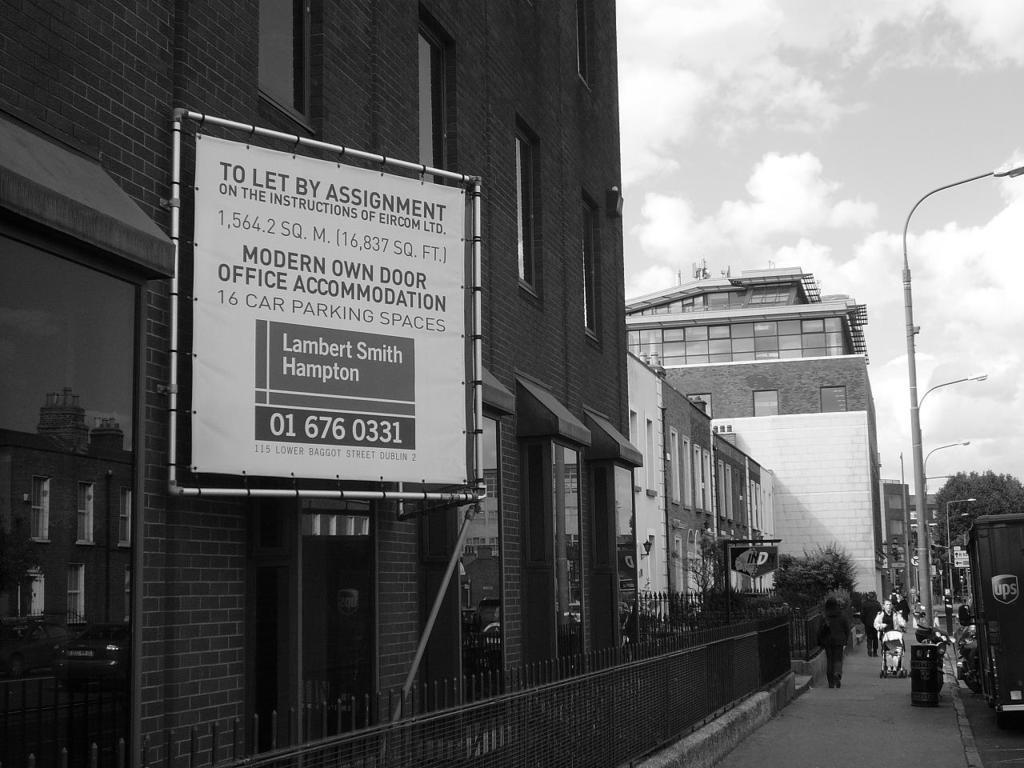Please provide a concise description of this image. This is a black and white image. To the right side, I can see few vehicles on the road. Beside the road I can see some street lights on the footpath and few people are walking here. To the left side there are some buildings and I can see a white color both is attached to a wall. In front of this building I can see a fencing. On the top of the image I can see the sky and clouds. 